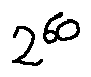Convert formula to latex. <formula><loc_0><loc_0><loc_500><loc_500>2 ^ { 6 0 }</formula> 